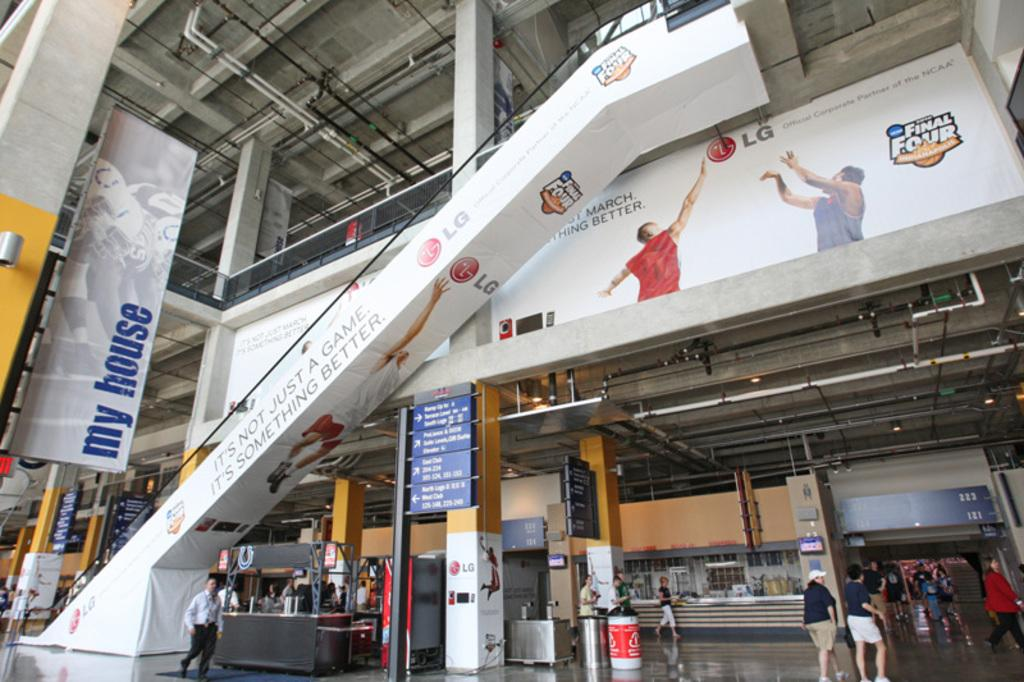What is the main structure in the center of the image? There is a building in the center of the image. What architectural features can be seen in the image? There are pillars in the image. What type of signage is present in the image? Banners and sign boards are visible in the image. What utilities can be seen in the image? Pipes are in the image. What type of furniture is present in the image? Tables are in the image. What type of waste disposal units are present in the image? Dust bins are present in the image. Are there any people in the image? Yes, there are people standing in the image. Can you describe any other objects in the image? There are other objects in the image, but their specific details are not mentioned in the provided facts. What type of calculator is being used by the person standing in the image? There is no calculator present in the image; people are standing but no specific tools or devices are mentioned. 